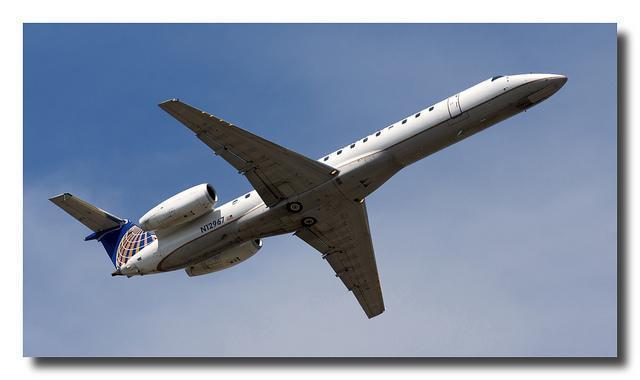How many people are in the picture?
Give a very brief answer. 0. 